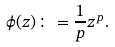Convert formula to latex. <formula><loc_0><loc_0><loc_500><loc_500>\phi ( z ) \colon = \frac { 1 } { p } z ^ { p } .</formula> 